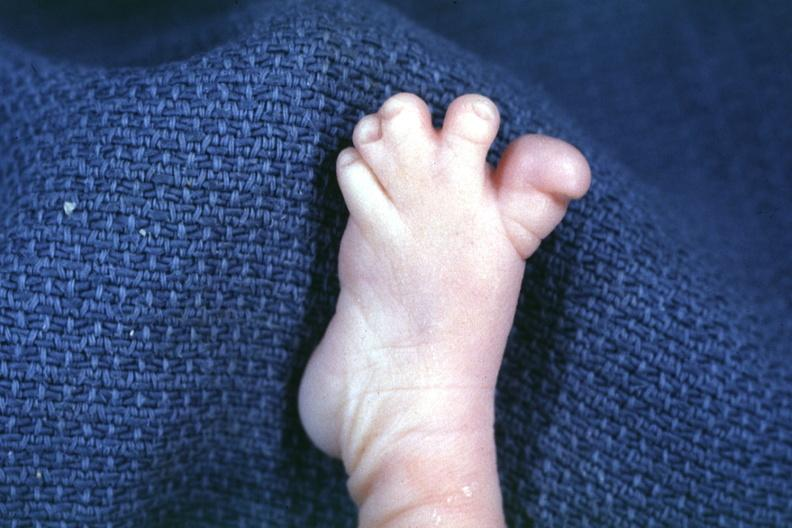re feet present?
Answer the question using a single word or phrase. No 